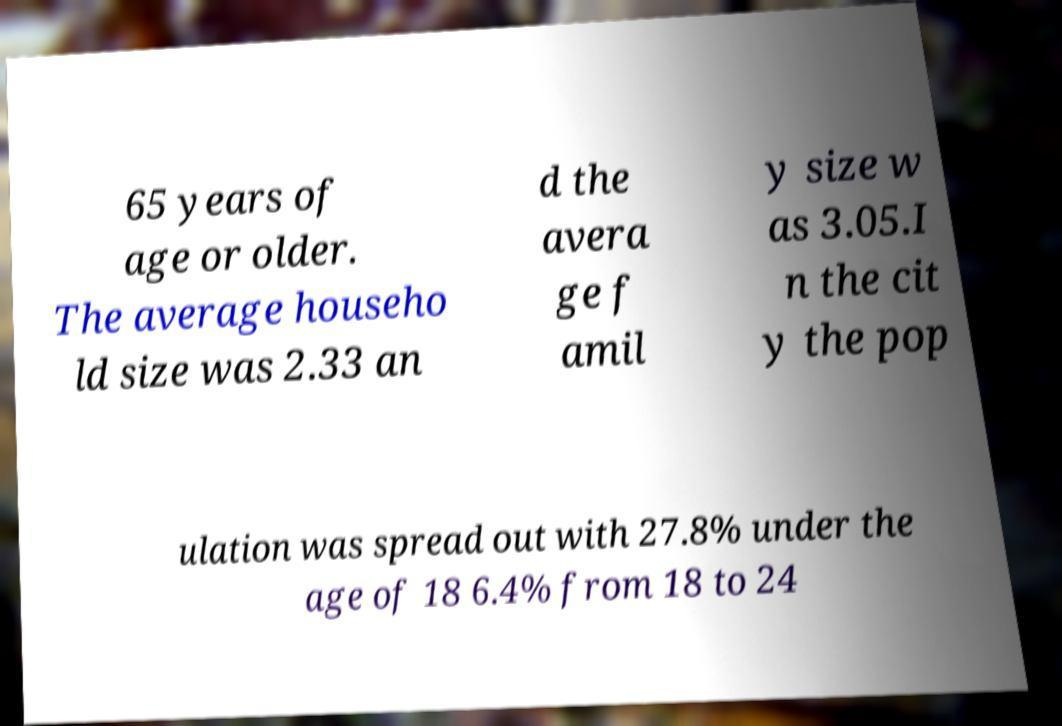What messages or text are displayed in this image? I need them in a readable, typed format. 65 years of age or older. The average househo ld size was 2.33 an d the avera ge f amil y size w as 3.05.I n the cit y the pop ulation was spread out with 27.8% under the age of 18 6.4% from 18 to 24 